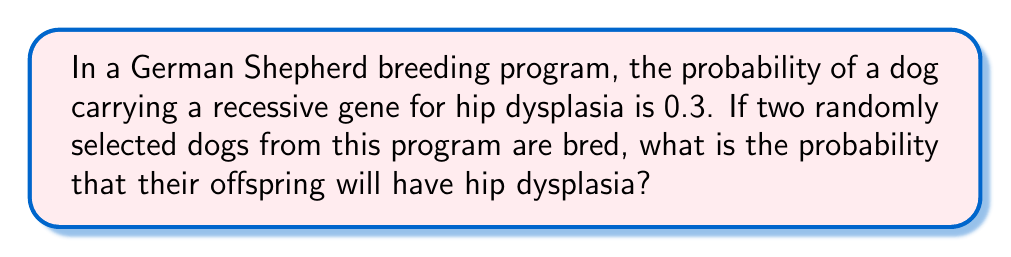What is the answer to this math problem? To solve this problem, we need to follow these steps:

1. Understand the genetic inheritance of hip dysplasia:
   - Hip dysplasia is a recessive genetic disorder.
   - For a puppy to have hip dysplasia, it must inherit the recessive gene from both parents.

2. Calculate the probability of each parent being a carrier:
   - Given probability of being a carrier = 0.3
   - Probability of not being a carrier = 1 - 0.3 = 0.7

3. Calculate the probability of both parents being carriers:
   $P(\text{both carriers}) = 0.3 \times 0.3 = 0.09$

4. If both parents are carriers, calculate the probability of the offspring inheriting the recessive gene from both parents:
   - Each carrier parent has a 50% chance of passing the recessive gene
   $P(\text{offspring inherits both recessive genes}) = 0.5 \times 0.5 = 0.25$

5. Calculate the final probability:
   $P(\text{hip dysplasia}) = P(\text{both parents carriers}) \times P(\text{offspring inherits both recessive genes})$
   $P(\text{hip dysplasia}) = 0.09 \times 0.25 = 0.0225$

Therefore, the probability that the offspring will have hip dysplasia is 0.0225 or 2.25%.
Answer: 0.0225 